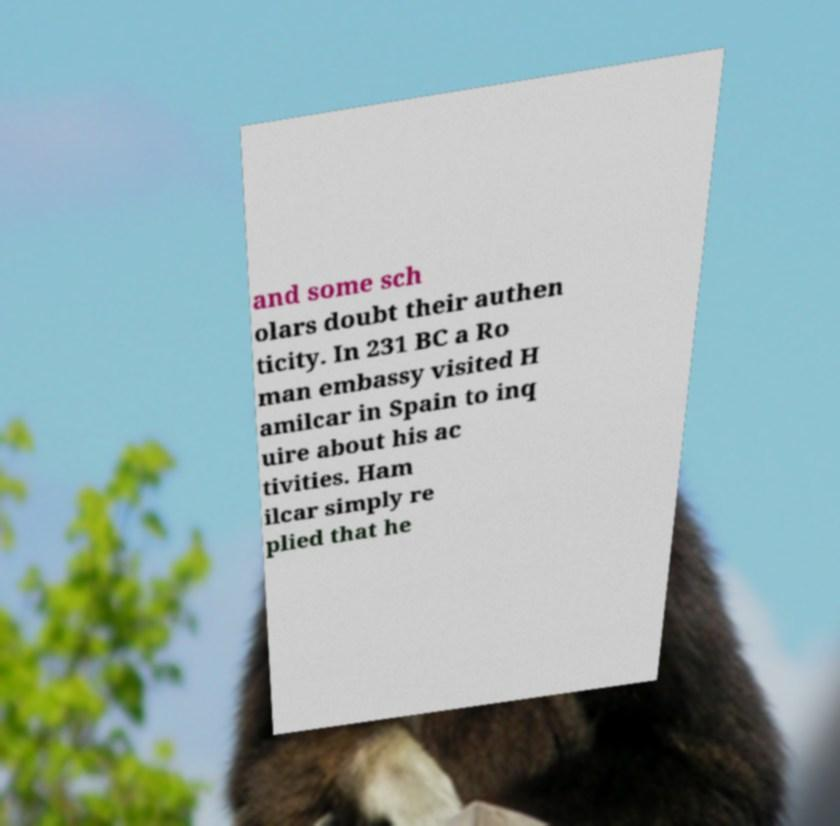I need the written content from this picture converted into text. Can you do that? and some sch olars doubt their authen ticity. In 231 BC a Ro man embassy visited H amilcar in Spain to inq uire about his ac tivities. Ham ilcar simply re plied that he 